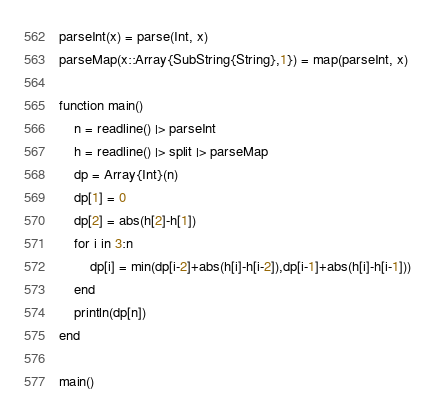Convert code to text. <code><loc_0><loc_0><loc_500><loc_500><_Julia_>parseInt(x) = parse(Int, x)
parseMap(x::Array{SubString{String},1}) = map(parseInt, x)

function main()
	n = readline() |> parseInt
	h = readline() |> split |> parseMap
	dp = Array{Int}(n)
	dp[1] = 0
	dp[2] = abs(h[2]-h[1])
	for i in 3:n
		dp[i] = min(dp[i-2]+abs(h[i]-h[i-2]),dp[i-1]+abs(h[i]-h[i-1]))
	end
	println(dp[n])
end

main()
</code> 